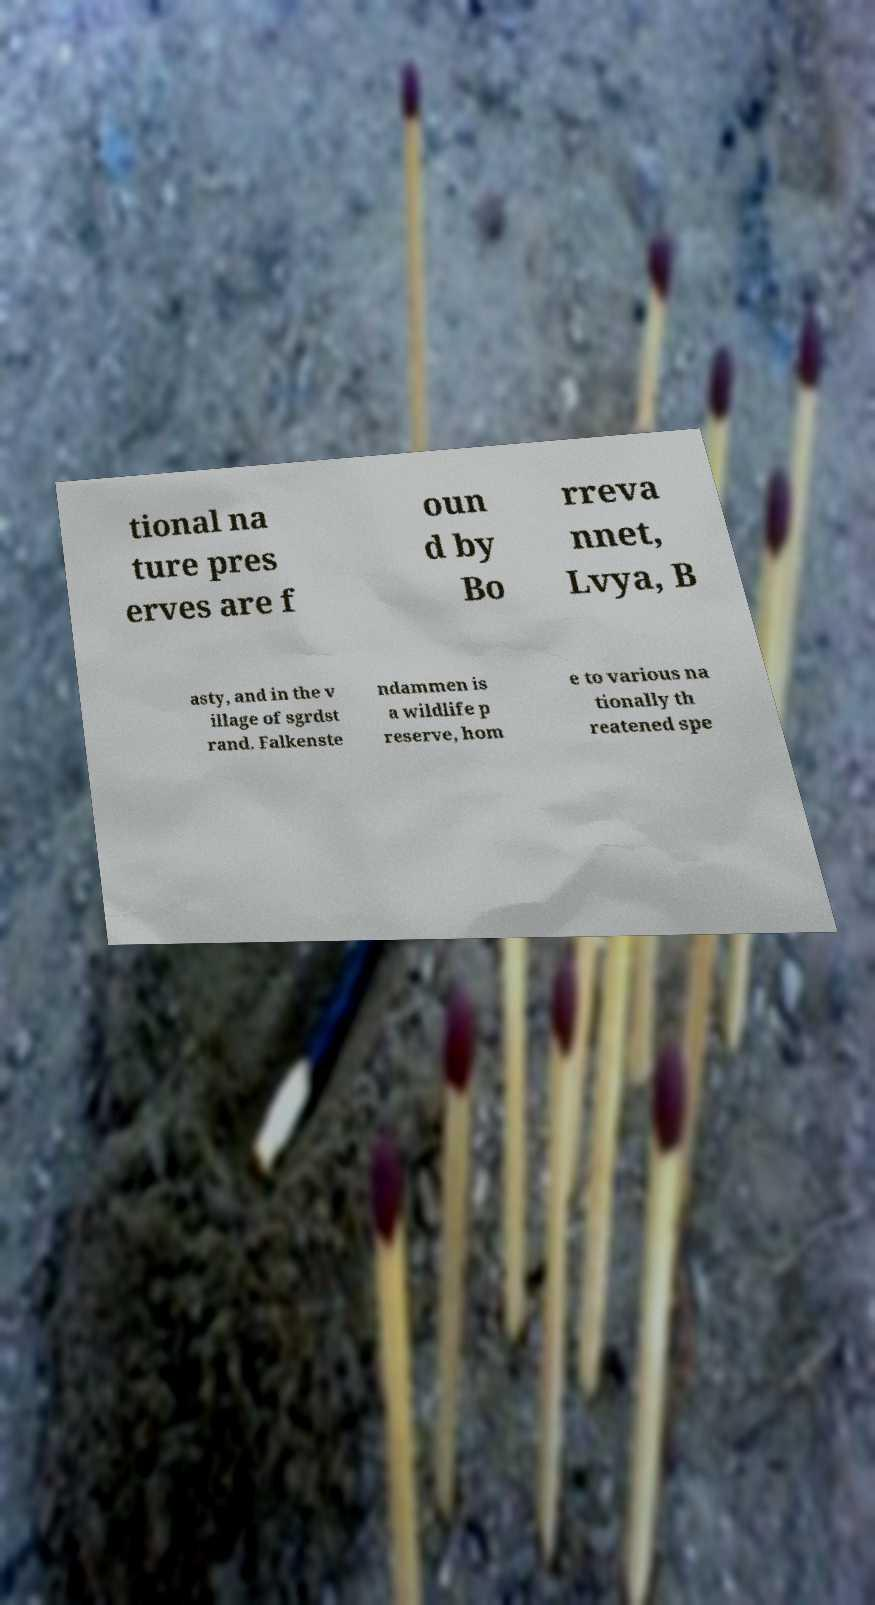I need the written content from this picture converted into text. Can you do that? tional na ture pres erves are f oun d by Bo rreva nnet, Lvya, B asty, and in the v illage of sgrdst rand. Falkenste ndammen is a wildlife p reserve, hom e to various na tionally th reatened spe 